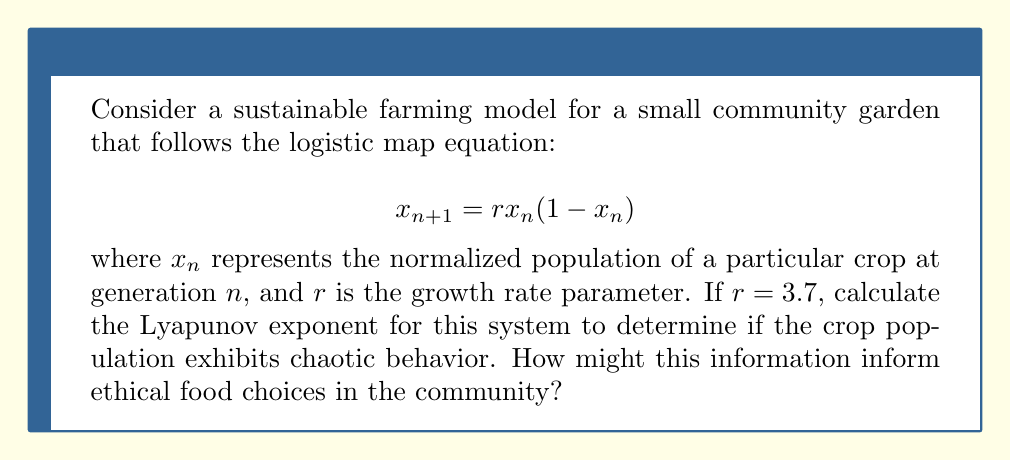Can you solve this math problem? To calculate the Lyapunov exponent for this logistic map:

1. The Lyapunov exponent $\lambda$ is given by:

   $$\lambda = \lim_{N \to \infty} \frac{1}{N} \sum_{n=0}^{N-1} \ln|f'(x_n)|$$

   where $f'(x_n)$ is the derivative of the logistic map function.

2. For the logistic map, $f'(x) = r(1-2x)$

3. We need to iterate the map and sum the logarithms:

   a. Start with an initial condition, e.g., $x_0 = 0.5$
   b. Iterate: $x_{n+1} = 3.7x_n(1-x_n)$
   c. Calculate $\ln|3.7(1-2x_n)|$ at each step
   d. Sum these values and divide by the number of iterations

4. Using a computer or calculator for 1000 iterations:

   $$\lambda \approx \frac{1}{1000} \sum_{n=0}^{999} \ln|3.7(1-2x_n)| \approx 0.3574$$

5. Since $\lambda > 0$, the system exhibits chaotic behavior.

This result indicates that the crop population in the sustainable farming model is sensitive to initial conditions and exhibits unpredictable long-term behavior. From an ethical perspective, this chaos in population dynamics suggests that careful monitoring and adaptive management practices are necessary to maintain a stable food supply. It also highlights the complexity of food production systems and the need for diverse, resilient agricultural approaches in community gardens.
Answer: $\lambda \approx 0.3574$ (positive, indicating chaotic behavior) 